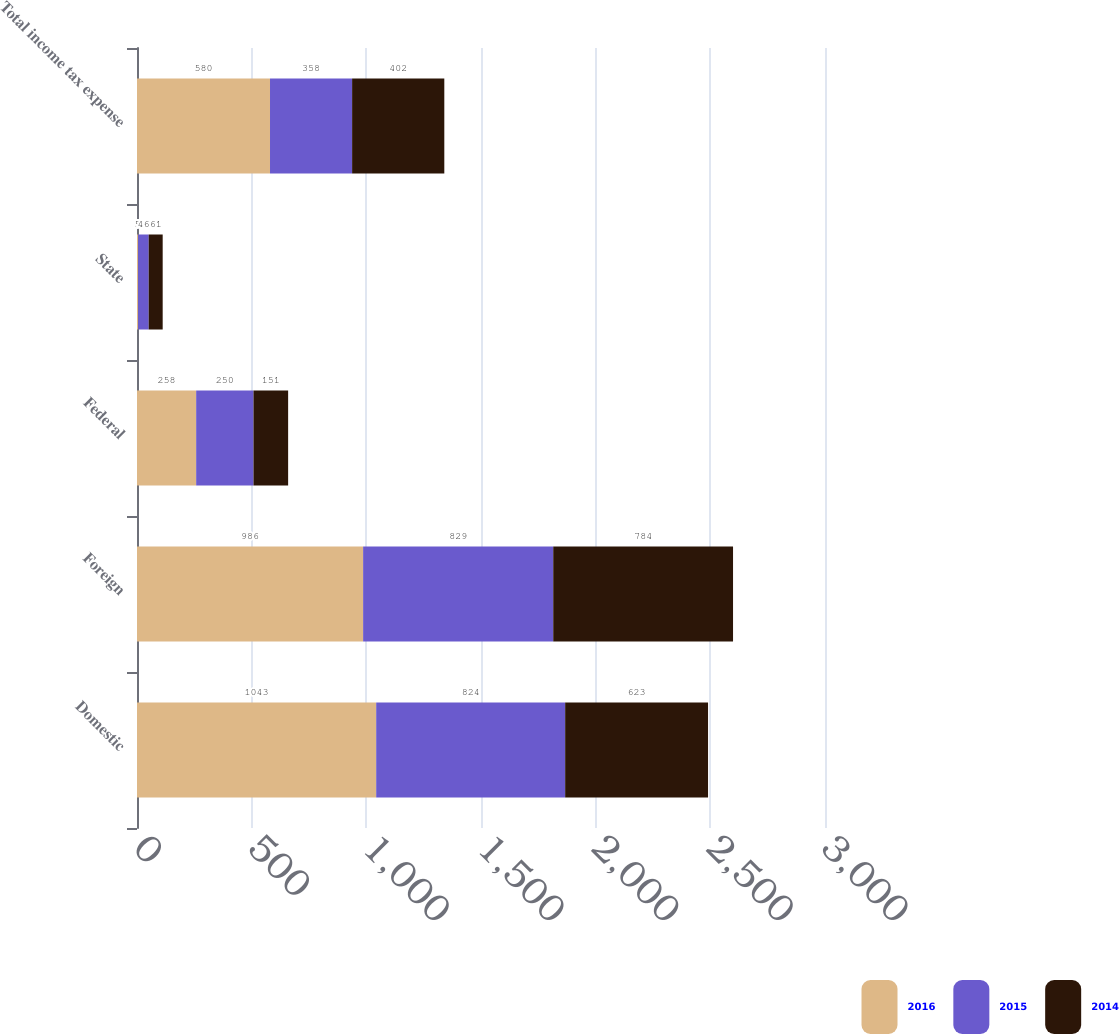Convert chart. <chart><loc_0><loc_0><loc_500><loc_500><stacked_bar_chart><ecel><fcel>Domestic<fcel>Foreign<fcel>Federal<fcel>State<fcel>Total income tax expense<nl><fcel>2016<fcel>1043<fcel>986<fcel>258<fcel>5<fcel>580<nl><fcel>2015<fcel>824<fcel>829<fcel>250<fcel>46<fcel>358<nl><fcel>2014<fcel>623<fcel>784<fcel>151<fcel>61<fcel>402<nl></chart> 